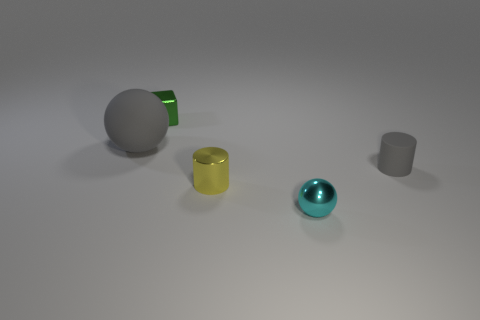Add 1 small green metallic cubes. How many objects exist? 6 Subtract all cubes. How many objects are left? 4 Subtract all tiny balls. Subtract all large matte balls. How many objects are left? 3 Add 2 tiny metal objects. How many tiny metal objects are left? 5 Add 2 brown rubber balls. How many brown rubber balls exist? 2 Subtract 0 cyan blocks. How many objects are left? 5 